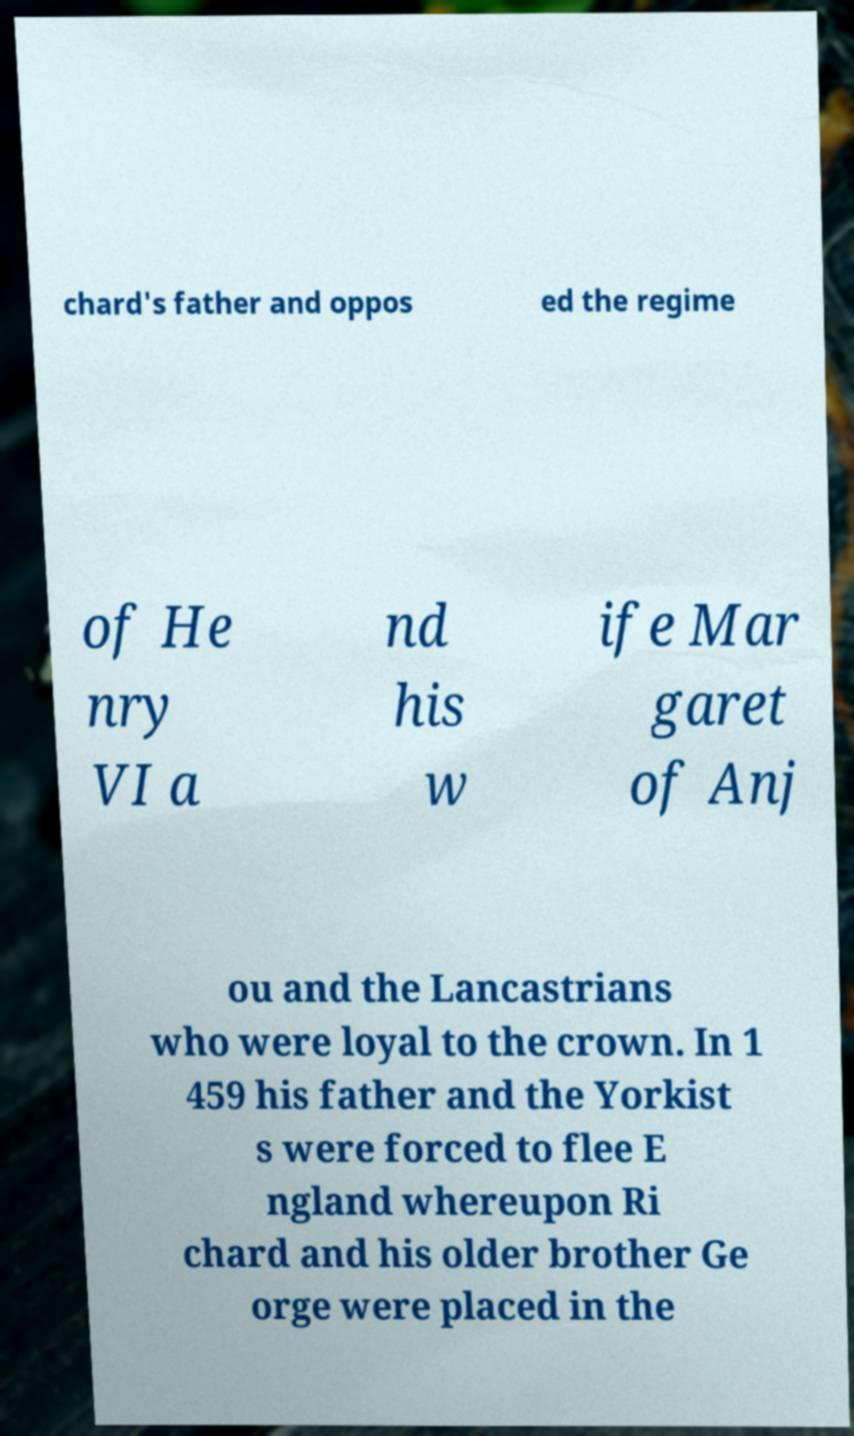Can you accurately transcribe the text from the provided image for me? chard's father and oppos ed the regime of He nry VI a nd his w ife Mar garet of Anj ou and the Lancastrians who were loyal to the crown. In 1 459 his father and the Yorkist s were forced to flee E ngland whereupon Ri chard and his older brother Ge orge were placed in the 